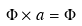<formula> <loc_0><loc_0><loc_500><loc_500>\Phi \times a = \Phi</formula> 